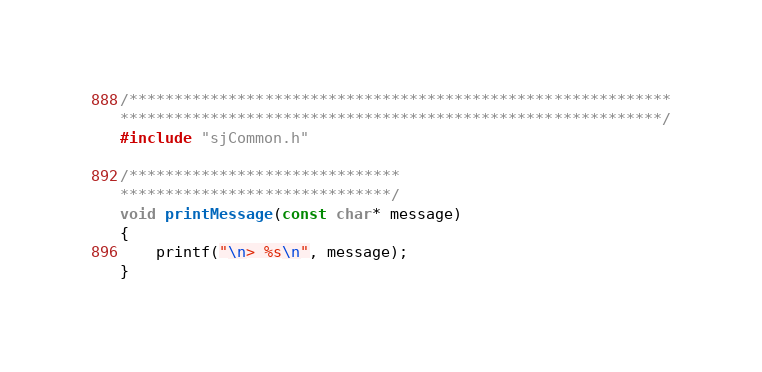<code> <loc_0><loc_0><loc_500><loc_500><_C++_>/************************************************************
************************************************************/
#include "sjCommon.h"

/******************************
******************************/
void printMessage(const char* message)
{
	printf("\n> %s\n", message);
}

</code> 